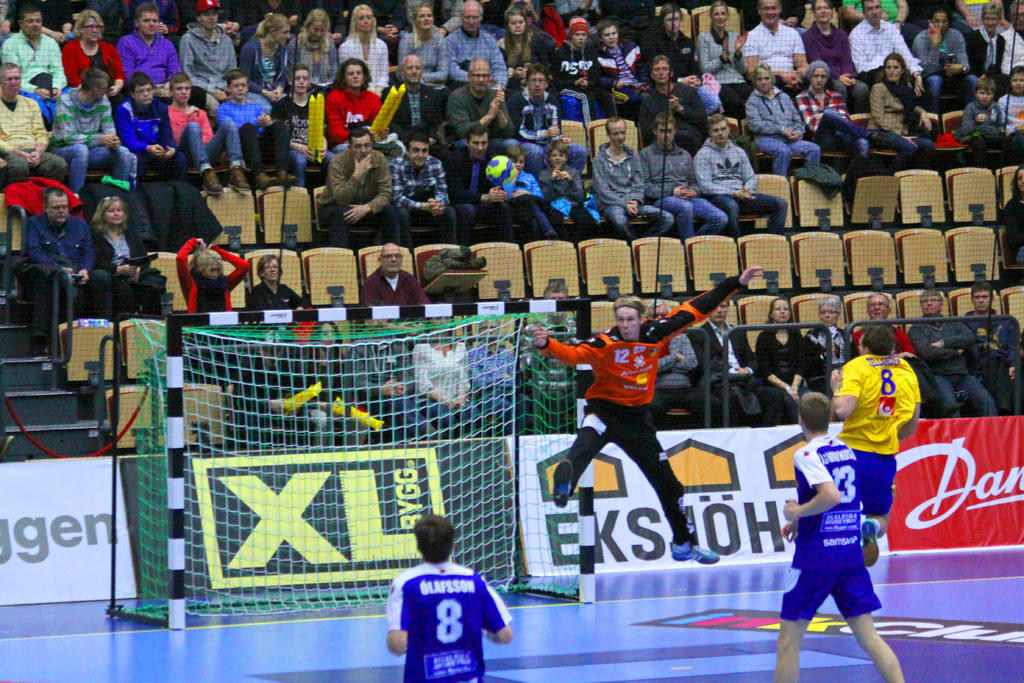What might the score be based on the players' body language? It's difficult to ascertain the exact score based solely on body language, but the attacking player's focus and the goalkeeper's readiness suggest that the game is competitive. 